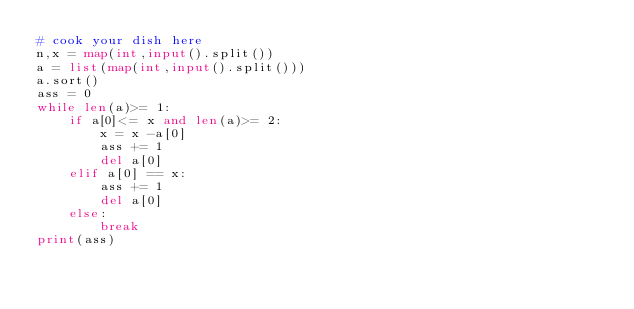Convert code to text. <code><loc_0><loc_0><loc_500><loc_500><_Python_># cook your dish here
n,x = map(int,input().split())
a = list(map(int,input().split()))
a.sort()
ass = 0
while len(a)>= 1:
    if a[0]<= x and len(a)>= 2:
        x = x -a[0]
        ass += 1
        del a[0]
    elif a[0] == x:
        ass += 1
        del a[0]
    else:
        break
print(ass)</code> 